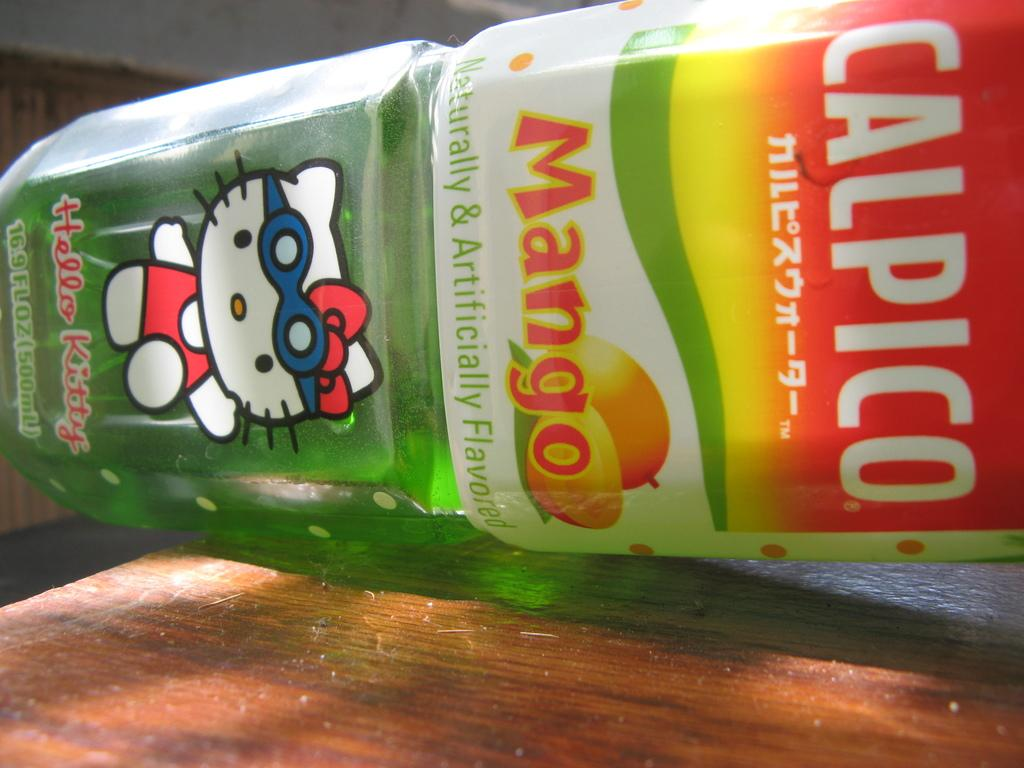<image>
Provide a brief description of the given image. a green bottle labeled as 'calpico mango' with hello kitty on it 